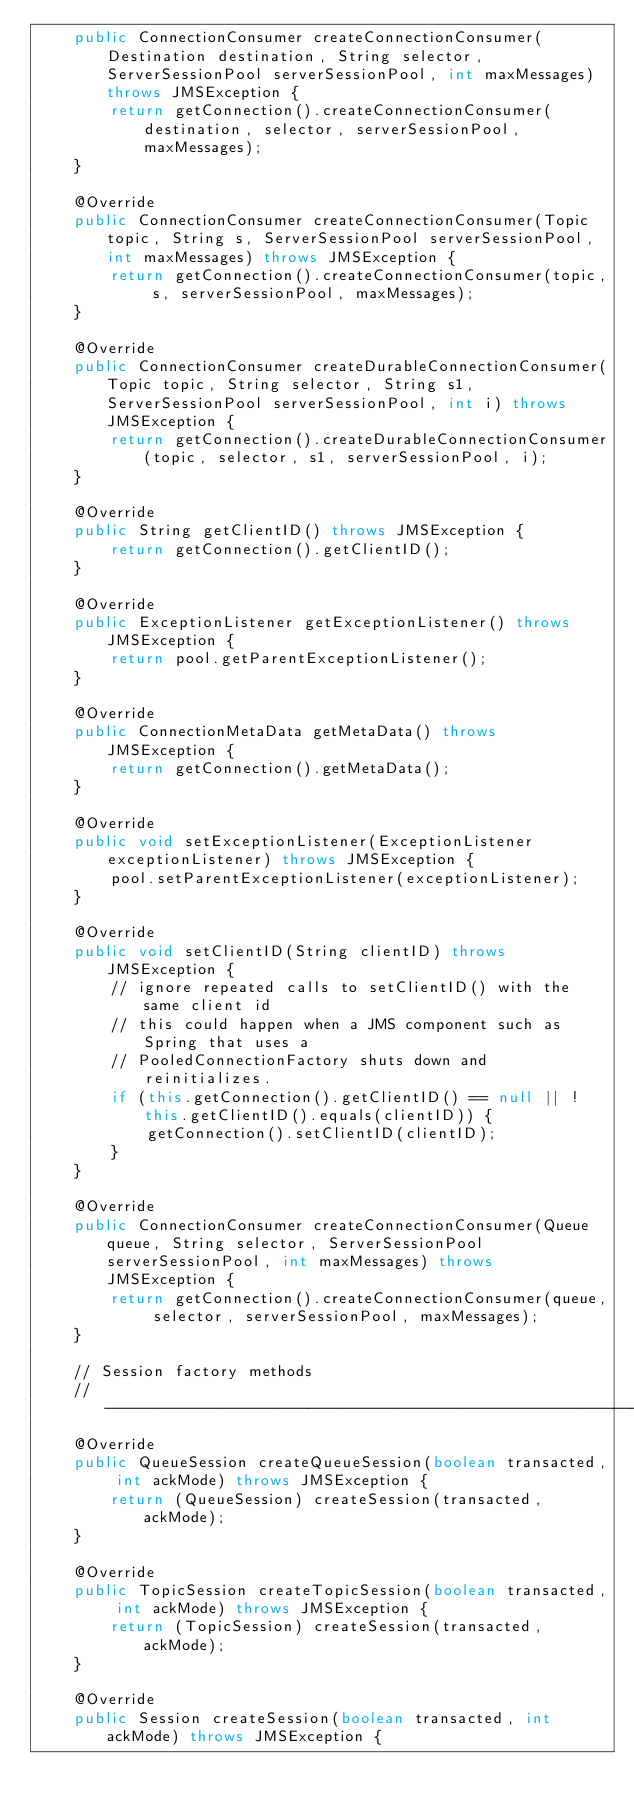Convert code to text. <code><loc_0><loc_0><loc_500><loc_500><_Java_>    public ConnectionConsumer createConnectionConsumer(Destination destination, String selector, ServerSessionPool serverSessionPool, int maxMessages) throws JMSException {
        return getConnection().createConnectionConsumer(destination, selector, serverSessionPool, maxMessages);
    }

    @Override
    public ConnectionConsumer createConnectionConsumer(Topic topic, String s, ServerSessionPool serverSessionPool, int maxMessages) throws JMSException {
        return getConnection().createConnectionConsumer(topic, s, serverSessionPool, maxMessages);
    }

    @Override
    public ConnectionConsumer createDurableConnectionConsumer(Topic topic, String selector, String s1, ServerSessionPool serverSessionPool, int i) throws JMSException {
        return getConnection().createDurableConnectionConsumer(topic, selector, s1, serverSessionPool, i);
    }

    @Override
    public String getClientID() throws JMSException {
        return getConnection().getClientID();
    }

    @Override
    public ExceptionListener getExceptionListener() throws JMSException {
        return pool.getParentExceptionListener();
    }

    @Override
    public ConnectionMetaData getMetaData() throws JMSException {
        return getConnection().getMetaData();
    }

    @Override
    public void setExceptionListener(ExceptionListener exceptionListener) throws JMSException {
        pool.setParentExceptionListener(exceptionListener);
    }

    @Override
    public void setClientID(String clientID) throws JMSException {
        // ignore repeated calls to setClientID() with the same client id
        // this could happen when a JMS component such as Spring that uses a
        // PooledConnectionFactory shuts down and reinitializes.
        if (this.getConnection().getClientID() == null || !this.getClientID().equals(clientID)) {
            getConnection().setClientID(clientID);
        }
    }

    @Override
    public ConnectionConsumer createConnectionConsumer(Queue queue, String selector, ServerSessionPool serverSessionPool, int maxMessages) throws JMSException {
        return getConnection().createConnectionConsumer(queue, selector, serverSessionPool, maxMessages);
    }

    // Session factory methods
    // -------------------------------------------------------------------------
    @Override
    public QueueSession createQueueSession(boolean transacted, int ackMode) throws JMSException {
        return (QueueSession) createSession(transacted, ackMode);
    }

    @Override
    public TopicSession createTopicSession(boolean transacted, int ackMode) throws JMSException {
        return (TopicSession) createSession(transacted, ackMode);
    }

    @Override
    public Session createSession(boolean transacted, int ackMode) throws JMSException {</code> 